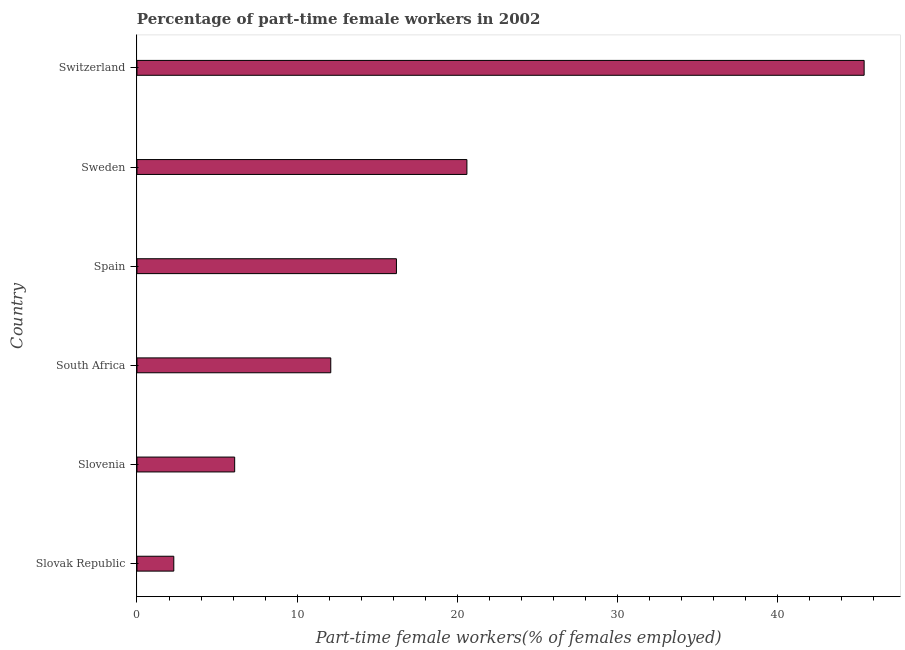Does the graph contain any zero values?
Your response must be concise. No. Does the graph contain grids?
Offer a terse response. No. What is the title of the graph?
Ensure brevity in your answer.  Percentage of part-time female workers in 2002. What is the label or title of the X-axis?
Provide a short and direct response. Part-time female workers(% of females employed). What is the label or title of the Y-axis?
Your answer should be very brief. Country. What is the percentage of part-time female workers in South Africa?
Offer a terse response. 12.1. Across all countries, what is the maximum percentage of part-time female workers?
Ensure brevity in your answer.  45.4. Across all countries, what is the minimum percentage of part-time female workers?
Ensure brevity in your answer.  2.3. In which country was the percentage of part-time female workers maximum?
Keep it short and to the point. Switzerland. In which country was the percentage of part-time female workers minimum?
Ensure brevity in your answer.  Slovak Republic. What is the sum of the percentage of part-time female workers?
Offer a very short reply. 102.7. What is the difference between the percentage of part-time female workers in Spain and Sweden?
Offer a very short reply. -4.4. What is the average percentage of part-time female workers per country?
Make the answer very short. 17.12. What is the median percentage of part-time female workers?
Ensure brevity in your answer.  14.15. In how many countries, is the percentage of part-time female workers greater than 32 %?
Keep it short and to the point. 1. What is the ratio of the percentage of part-time female workers in Slovak Republic to that in Sweden?
Ensure brevity in your answer.  0.11. Is the difference between the percentage of part-time female workers in Slovak Republic and Switzerland greater than the difference between any two countries?
Give a very brief answer. Yes. What is the difference between the highest and the second highest percentage of part-time female workers?
Your response must be concise. 24.8. Is the sum of the percentage of part-time female workers in South Africa and Spain greater than the maximum percentage of part-time female workers across all countries?
Provide a succinct answer. No. What is the difference between the highest and the lowest percentage of part-time female workers?
Keep it short and to the point. 43.1. How many bars are there?
Ensure brevity in your answer.  6. How many countries are there in the graph?
Offer a terse response. 6. What is the Part-time female workers(% of females employed) in Slovak Republic?
Provide a short and direct response. 2.3. What is the Part-time female workers(% of females employed) of Slovenia?
Provide a short and direct response. 6.1. What is the Part-time female workers(% of females employed) in South Africa?
Your answer should be compact. 12.1. What is the Part-time female workers(% of females employed) in Spain?
Provide a short and direct response. 16.2. What is the Part-time female workers(% of females employed) of Sweden?
Make the answer very short. 20.6. What is the Part-time female workers(% of females employed) in Switzerland?
Give a very brief answer. 45.4. What is the difference between the Part-time female workers(% of females employed) in Slovak Republic and Sweden?
Offer a terse response. -18.3. What is the difference between the Part-time female workers(% of females employed) in Slovak Republic and Switzerland?
Your response must be concise. -43.1. What is the difference between the Part-time female workers(% of females employed) in Slovenia and South Africa?
Your answer should be compact. -6. What is the difference between the Part-time female workers(% of females employed) in Slovenia and Sweden?
Your response must be concise. -14.5. What is the difference between the Part-time female workers(% of females employed) in Slovenia and Switzerland?
Your response must be concise. -39.3. What is the difference between the Part-time female workers(% of females employed) in South Africa and Spain?
Your answer should be compact. -4.1. What is the difference between the Part-time female workers(% of females employed) in South Africa and Switzerland?
Provide a short and direct response. -33.3. What is the difference between the Part-time female workers(% of females employed) in Spain and Sweden?
Make the answer very short. -4.4. What is the difference between the Part-time female workers(% of females employed) in Spain and Switzerland?
Ensure brevity in your answer.  -29.2. What is the difference between the Part-time female workers(% of females employed) in Sweden and Switzerland?
Your answer should be compact. -24.8. What is the ratio of the Part-time female workers(% of females employed) in Slovak Republic to that in Slovenia?
Provide a short and direct response. 0.38. What is the ratio of the Part-time female workers(% of females employed) in Slovak Republic to that in South Africa?
Provide a succinct answer. 0.19. What is the ratio of the Part-time female workers(% of females employed) in Slovak Republic to that in Spain?
Your response must be concise. 0.14. What is the ratio of the Part-time female workers(% of females employed) in Slovak Republic to that in Sweden?
Ensure brevity in your answer.  0.11. What is the ratio of the Part-time female workers(% of females employed) in Slovak Republic to that in Switzerland?
Keep it short and to the point. 0.05. What is the ratio of the Part-time female workers(% of females employed) in Slovenia to that in South Africa?
Make the answer very short. 0.5. What is the ratio of the Part-time female workers(% of females employed) in Slovenia to that in Spain?
Your response must be concise. 0.38. What is the ratio of the Part-time female workers(% of females employed) in Slovenia to that in Sweden?
Your answer should be compact. 0.3. What is the ratio of the Part-time female workers(% of females employed) in Slovenia to that in Switzerland?
Offer a terse response. 0.13. What is the ratio of the Part-time female workers(% of females employed) in South Africa to that in Spain?
Offer a terse response. 0.75. What is the ratio of the Part-time female workers(% of females employed) in South Africa to that in Sweden?
Keep it short and to the point. 0.59. What is the ratio of the Part-time female workers(% of females employed) in South Africa to that in Switzerland?
Your answer should be very brief. 0.27. What is the ratio of the Part-time female workers(% of females employed) in Spain to that in Sweden?
Provide a succinct answer. 0.79. What is the ratio of the Part-time female workers(% of females employed) in Spain to that in Switzerland?
Your answer should be very brief. 0.36. What is the ratio of the Part-time female workers(% of females employed) in Sweden to that in Switzerland?
Provide a succinct answer. 0.45. 